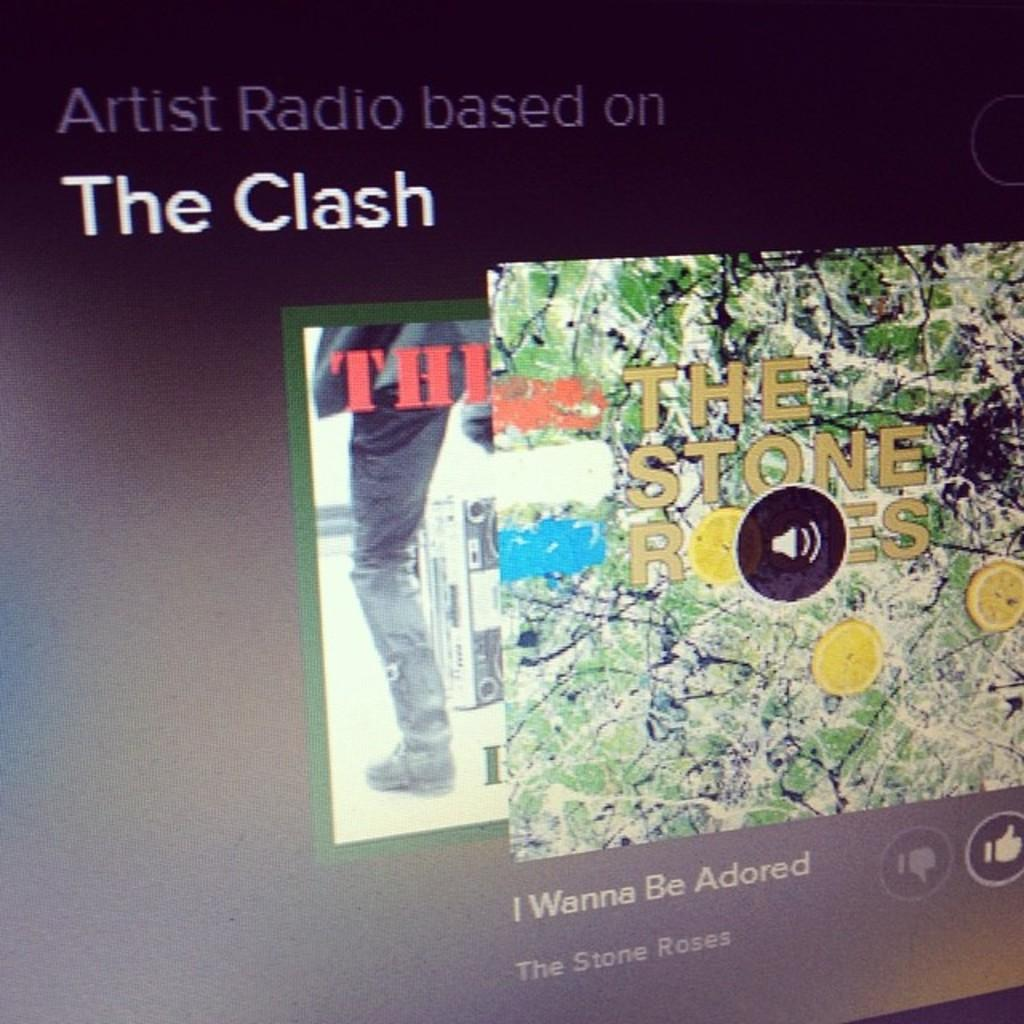<image>
Relay a brief, clear account of the picture shown. The Clash's album The Stone Roses is on a screen. 